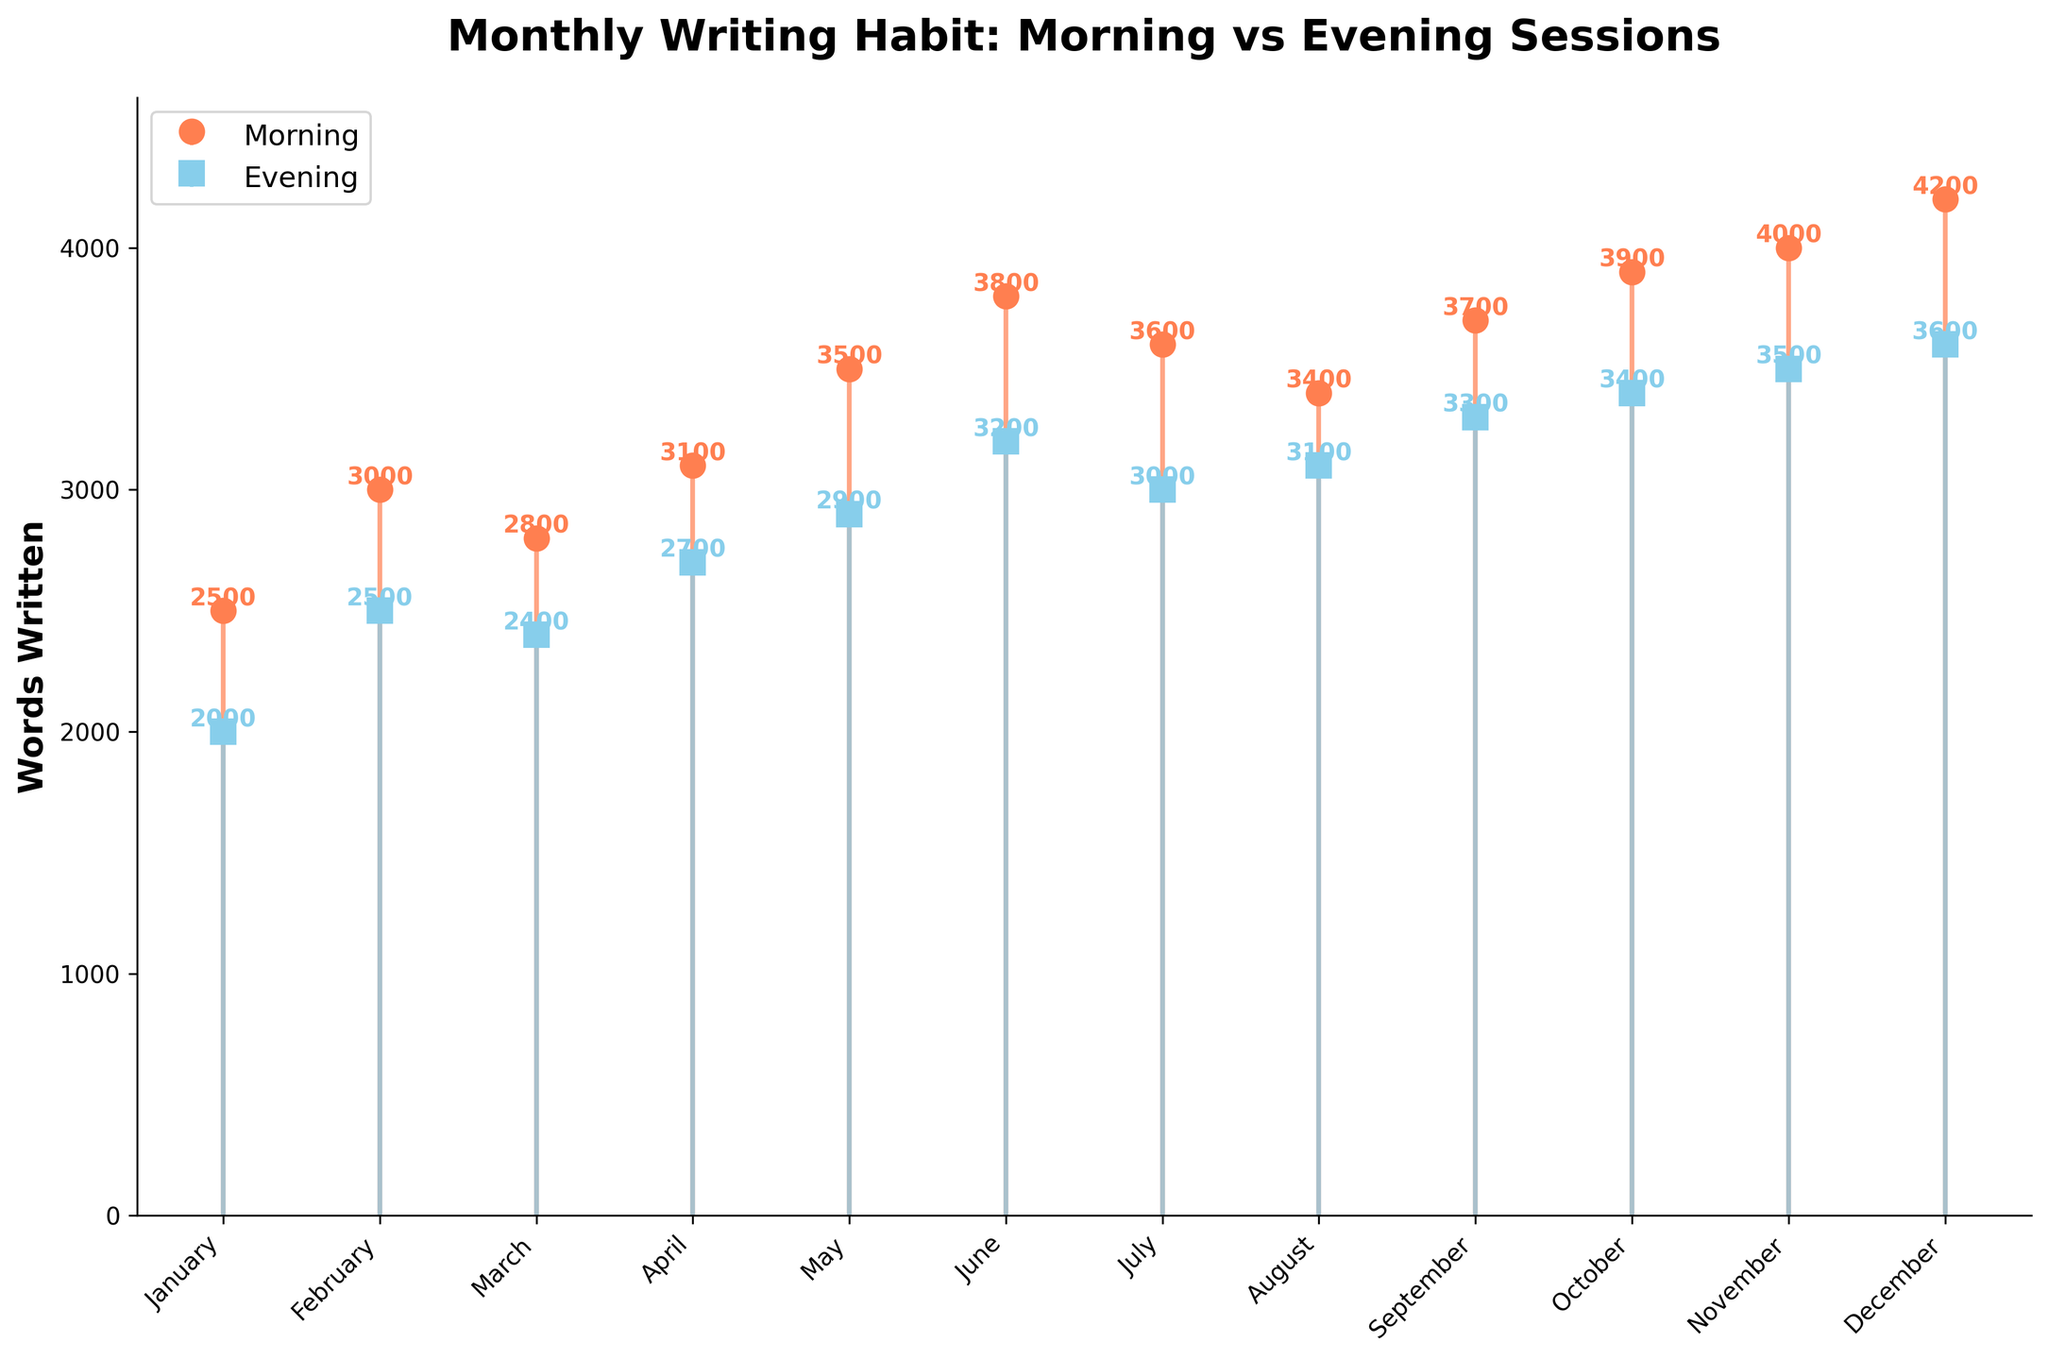What is the title of the plot? The title of the plot is displayed at the top of the figure. It provides an overview of what the plot is describing.
Answer: Monthly Writing Habit: Morning vs Evening Sessions Which month has the highest word count in morning sessions? By looking at the orange markers representing morning sessions, we see that December has the highest word count.
Answer: December How many words did aspiring authors write in the evening session in July? Examine the blue marker for July to find the corresponding number of words. The point is labeled 3000.
Answer: 3000 What is the average word count for morning sessions across all months? Add up all the values for morning sessions (2500 + 3000 + 2800 + 3100 + 3500 + 3800 + 3600 + 3400 + 3700 + 3900 + 4000 + 4200), which equals 42500, then divide by the 12 months.
Answer: 3541.67 Do aspiring authors tend to write more words in the morning or evening on average? Calculate the average word count for both sessions. Morning: 3541.67, Evening: (2000 + 2500 + 2400 + 2700 + 2900 + 3200 + 3000 + 3100 + 3300 + 3400 + 3500 + 3600) / 12 = 2916.67. Morning is higher.
Answer: Morning Which month(s) show an equal word count for morning and evening sessions? Compare the word counts for each month. There is no month where morning and evening word counts are equal.
Answer: None What is the total word count for both morning and evening sessions in February? Add the word counts for both sessions in February: Morning (3000) + Evening (2500) = 5500.
Answer: 5500 How many more words were written in the morning than in the evening in October? Subtract the evening word count from the morning word count for October: 3900 - 3400 = 500.
Answer: 500 Between which two consecutive months is there the largest increase in morning session word count? Calculate the differences between consecutive months for morning sessions: Feb-Jan (3000-2500), Apr-Mar (3100-2800), May-Apr (3500-3100), June-May (3800-3500), Sept-Aug (3700-3400), Oct-Sept (3900-3700), and Nov-Oct (4000-3900). The largest increase is from May to June (300).
Answer: May to June Is there any month where the word count decreased both in morning and evening sessions compared to the previous month? Check each month's word counts: Between March-April and May-June, both sessions saw increases. Identify the only decrease between May-June and July, and October-September. So, No month noticed a decrease in both sessions.
Answer: No 